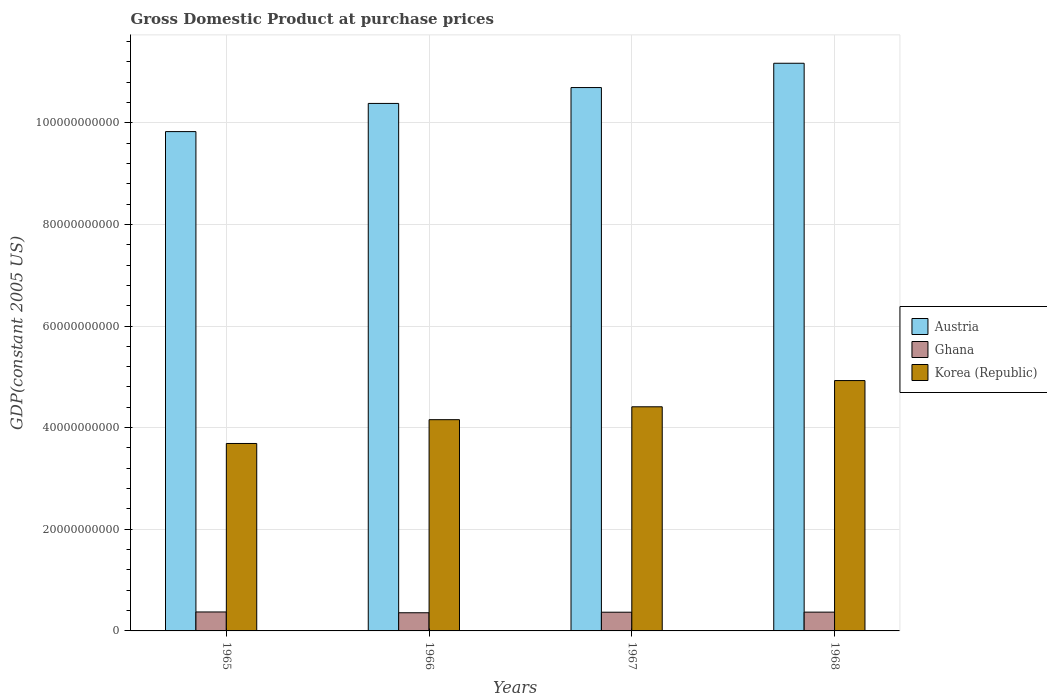How many groups of bars are there?
Offer a very short reply. 4. Are the number of bars on each tick of the X-axis equal?
Keep it short and to the point. Yes. How many bars are there on the 3rd tick from the right?
Your answer should be compact. 3. What is the label of the 3rd group of bars from the left?
Make the answer very short. 1967. In how many cases, is the number of bars for a given year not equal to the number of legend labels?
Your response must be concise. 0. What is the GDP at purchase prices in Austria in 1966?
Ensure brevity in your answer.  1.04e+11. Across all years, what is the maximum GDP at purchase prices in Ghana?
Your answer should be very brief. 3.73e+09. Across all years, what is the minimum GDP at purchase prices in Ghana?
Your response must be concise. 3.57e+09. In which year was the GDP at purchase prices in Korea (Republic) maximum?
Ensure brevity in your answer.  1968. In which year was the GDP at purchase prices in Korea (Republic) minimum?
Your response must be concise. 1965. What is the total GDP at purchase prices in Ghana in the graph?
Provide a short and direct response. 1.47e+1. What is the difference between the GDP at purchase prices in Austria in 1965 and that in 1968?
Keep it short and to the point. -1.34e+1. What is the difference between the GDP at purchase prices in Ghana in 1968 and the GDP at purchase prices in Austria in 1965?
Provide a succinct answer. -9.46e+1. What is the average GDP at purchase prices in Ghana per year?
Make the answer very short. 3.67e+09. In the year 1967, what is the difference between the GDP at purchase prices in Korea (Republic) and GDP at purchase prices in Austria?
Your answer should be very brief. -6.28e+1. In how many years, is the GDP at purchase prices in Korea (Republic) greater than 8000000000 US$?
Make the answer very short. 4. What is the ratio of the GDP at purchase prices in Austria in 1965 to that in 1968?
Ensure brevity in your answer.  0.88. What is the difference between the highest and the second highest GDP at purchase prices in Ghana?
Ensure brevity in your answer.  3.54e+07. What is the difference between the highest and the lowest GDP at purchase prices in Korea (Republic)?
Provide a succinct answer. 1.24e+1. In how many years, is the GDP at purchase prices in Ghana greater than the average GDP at purchase prices in Ghana taken over all years?
Provide a succinct answer. 3. Is the sum of the GDP at purchase prices in Austria in 1965 and 1967 greater than the maximum GDP at purchase prices in Korea (Republic) across all years?
Provide a succinct answer. Yes. What does the 1st bar from the left in 1968 represents?
Keep it short and to the point. Austria. How many bars are there?
Offer a terse response. 12. How many legend labels are there?
Keep it short and to the point. 3. How are the legend labels stacked?
Offer a terse response. Vertical. What is the title of the graph?
Provide a short and direct response. Gross Domestic Product at purchase prices. Does "Hong Kong" appear as one of the legend labels in the graph?
Provide a short and direct response. No. What is the label or title of the Y-axis?
Provide a succinct answer. GDP(constant 2005 US). What is the GDP(constant 2005 US) in Austria in 1965?
Ensure brevity in your answer.  9.83e+1. What is the GDP(constant 2005 US) of Ghana in 1965?
Your answer should be compact. 3.73e+09. What is the GDP(constant 2005 US) in Korea (Republic) in 1965?
Your answer should be very brief. 3.69e+1. What is the GDP(constant 2005 US) in Austria in 1966?
Your answer should be compact. 1.04e+11. What is the GDP(constant 2005 US) in Ghana in 1966?
Offer a very short reply. 3.57e+09. What is the GDP(constant 2005 US) of Korea (Republic) in 1966?
Your response must be concise. 4.16e+1. What is the GDP(constant 2005 US) of Austria in 1967?
Offer a terse response. 1.07e+11. What is the GDP(constant 2005 US) in Ghana in 1967?
Provide a short and direct response. 3.68e+09. What is the GDP(constant 2005 US) of Korea (Republic) in 1967?
Provide a short and direct response. 4.41e+1. What is the GDP(constant 2005 US) of Austria in 1968?
Your answer should be very brief. 1.12e+11. What is the GDP(constant 2005 US) in Ghana in 1968?
Offer a terse response. 3.70e+09. What is the GDP(constant 2005 US) of Korea (Republic) in 1968?
Give a very brief answer. 4.93e+1. Across all years, what is the maximum GDP(constant 2005 US) of Austria?
Your answer should be compact. 1.12e+11. Across all years, what is the maximum GDP(constant 2005 US) of Ghana?
Ensure brevity in your answer.  3.73e+09. Across all years, what is the maximum GDP(constant 2005 US) of Korea (Republic)?
Provide a short and direct response. 4.93e+1. Across all years, what is the minimum GDP(constant 2005 US) in Austria?
Ensure brevity in your answer.  9.83e+1. Across all years, what is the minimum GDP(constant 2005 US) of Ghana?
Provide a short and direct response. 3.57e+09. Across all years, what is the minimum GDP(constant 2005 US) in Korea (Republic)?
Offer a very short reply. 3.69e+1. What is the total GDP(constant 2005 US) in Austria in the graph?
Provide a succinct answer. 4.21e+11. What is the total GDP(constant 2005 US) of Ghana in the graph?
Your answer should be compact. 1.47e+1. What is the total GDP(constant 2005 US) in Korea (Republic) in the graph?
Give a very brief answer. 1.72e+11. What is the difference between the GDP(constant 2005 US) of Austria in 1965 and that in 1966?
Provide a short and direct response. -5.54e+09. What is the difference between the GDP(constant 2005 US) of Ghana in 1965 and that in 1966?
Ensure brevity in your answer.  1.59e+08. What is the difference between the GDP(constant 2005 US) in Korea (Republic) in 1965 and that in 1966?
Your response must be concise. -4.68e+09. What is the difference between the GDP(constant 2005 US) in Austria in 1965 and that in 1967?
Your response must be concise. -8.67e+09. What is the difference between the GDP(constant 2005 US) of Ghana in 1965 and that in 1967?
Your response must be concise. 4.90e+07. What is the difference between the GDP(constant 2005 US) of Korea (Republic) in 1965 and that in 1967?
Your answer should be compact. -7.22e+09. What is the difference between the GDP(constant 2005 US) of Austria in 1965 and that in 1968?
Give a very brief answer. -1.34e+1. What is the difference between the GDP(constant 2005 US) in Ghana in 1965 and that in 1968?
Offer a very short reply. 3.54e+07. What is the difference between the GDP(constant 2005 US) of Korea (Republic) in 1965 and that in 1968?
Your answer should be compact. -1.24e+1. What is the difference between the GDP(constant 2005 US) of Austria in 1966 and that in 1967?
Your answer should be very brief. -3.12e+09. What is the difference between the GDP(constant 2005 US) in Ghana in 1966 and that in 1967?
Provide a succinct answer. -1.10e+08. What is the difference between the GDP(constant 2005 US) of Korea (Republic) in 1966 and that in 1967?
Give a very brief answer. -2.54e+09. What is the difference between the GDP(constant 2005 US) of Austria in 1966 and that in 1968?
Provide a short and direct response. -7.90e+09. What is the difference between the GDP(constant 2005 US) of Ghana in 1966 and that in 1968?
Your response must be concise. -1.23e+08. What is the difference between the GDP(constant 2005 US) of Korea (Republic) in 1966 and that in 1968?
Keep it short and to the point. -7.70e+09. What is the difference between the GDP(constant 2005 US) of Austria in 1967 and that in 1968?
Your answer should be very brief. -4.78e+09. What is the difference between the GDP(constant 2005 US) of Ghana in 1967 and that in 1968?
Your answer should be very brief. -1.36e+07. What is the difference between the GDP(constant 2005 US) of Korea (Republic) in 1967 and that in 1968?
Your answer should be very brief. -5.16e+09. What is the difference between the GDP(constant 2005 US) in Austria in 1965 and the GDP(constant 2005 US) in Ghana in 1966?
Ensure brevity in your answer.  9.47e+1. What is the difference between the GDP(constant 2005 US) in Austria in 1965 and the GDP(constant 2005 US) in Korea (Republic) in 1966?
Ensure brevity in your answer.  5.67e+1. What is the difference between the GDP(constant 2005 US) in Ghana in 1965 and the GDP(constant 2005 US) in Korea (Republic) in 1966?
Your answer should be compact. -3.78e+1. What is the difference between the GDP(constant 2005 US) in Austria in 1965 and the GDP(constant 2005 US) in Ghana in 1967?
Provide a succinct answer. 9.46e+1. What is the difference between the GDP(constant 2005 US) in Austria in 1965 and the GDP(constant 2005 US) in Korea (Republic) in 1967?
Offer a terse response. 5.42e+1. What is the difference between the GDP(constant 2005 US) in Ghana in 1965 and the GDP(constant 2005 US) in Korea (Republic) in 1967?
Your response must be concise. -4.04e+1. What is the difference between the GDP(constant 2005 US) of Austria in 1965 and the GDP(constant 2005 US) of Ghana in 1968?
Make the answer very short. 9.46e+1. What is the difference between the GDP(constant 2005 US) of Austria in 1965 and the GDP(constant 2005 US) of Korea (Republic) in 1968?
Provide a short and direct response. 4.90e+1. What is the difference between the GDP(constant 2005 US) in Ghana in 1965 and the GDP(constant 2005 US) in Korea (Republic) in 1968?
Your response must be concise. -4.55e+1. What is the difference between the GDP(constant 2005 US) in Austria in 1966 and the GDP(constant 2005 US) in Ghana in 1967?
Your response must be concise. 1.00e+11. What is the difference between the GDP(constant 2005 US) of Austria in 1966 and the GDP(constant 2005 US) of Korea (Republic) in 1967?
Your answer should be compact. 5.97e+1. What is the difference between the GDP(constant 2005 US) in Ghana in 1966 and the GDP(constant 2005 US) in Korea (Republic) in 1967?
Give a very brief answer. -4.05e+1. What is the difference between the GDP(constant 2005 US) in Austria in 1966 and the GDP(constant 2005 US) in Ghana in 1968?
Make the answer very short. 1.00e+11. What is the difference between the GDP(constant 2005 US) in Austria in 1966 and the GDP(constant 2005 US) in Korea (Republic) in 1968?
Provide a succinct answer. 5.45e+1. What is the difference between the GDP(constant 2005 US) in Ghana in 1966 and the GDP(constant 2005 US) in Korea (Republic) in 1968?
Your answer should be very brief. -4.57e+1. What is the difference between the GDP(constant 2005 US) of Austria in 1967 and the GDP(constant 2005 US) of Ghana in 1968?
Offer a terse response. 1.03e+11. What is the difference between the GDP(constant 2005 US) in Austria in 1967 and the GDP(constant 2005 US) in Korea (Republic) in 1968?
Your answer should be compact. 5.77e+1. What is the difference between the GDP(constant 2005 US) of Ghana in 1967 and the GDP(constant 2005 US) of Korea (Republic) in 1968?
Give a very brief answer. -4.56e+1. What is the average GDP(constant 2005 US) in Austria per year?
Provide a short and direct response. 1.05e+11. What is the average GDP(constant 2005 US) of Ghana per year?
Give a very brief answer. 3.67e+09. What is the average GDP(constant 2005 US) in Korea (Republic) per year?
Ensure brevity in your answer.  4.30e+1. In the year 1965, what is the difference between the GDP(constant 2005 US) of Austria and GDP(constant 2005 US) of Ghana?
Keep it short and to the point. 9.45e+1. In the year 1965, what is the difference between the GDP(constant 2005 US) of Austria and GDP(constant 2005 US) of Korea (Republic)?
Your response must be concise. 6.14e+1. In the year 1965, what is the difference between the GDP(constant 2005 US) in Ghana and GDP(constant 2005 US) in Korea (Republic)?
Ensure brevity in your answer.  -3.32e+1. In the year 1966, what is the difference between the GDP(constant 2005 US) in Austria and GDP(constant 2005 US) in Ghana?
Your answer should be compact. 1.00e+11. In the year 1966, what is the difference between the GDP(constant 2005 US) of Austria and GDP(constant 2005 US) of Korea (Republic)?
Ensure brevity in your answer.  6.22e+1. In the year 1966, what is the difference between the GDP(constant 2005 US) in Ghana and GDP(constant 2005 US) in Korea (Republic)?
Offer a terse response. -3.80e+1. In the year 1967, what is the difference between the GDP(constant 2005 US) in Austria and GDP(constant 2005 US) in Ghana?
Offer a very short reply. 1.03e+11. In the year 1967, what is the difference between the GDP(constant 2005 US) of Austria and GDP(constant 2005 US) of Korea (Republic)?
Keep it short and to the point. 6.28e+1. In the year 1967, what is the difference between the GDP(constant 2005 US) of Ghana and GDP(constant 2005 US) of Korea (Republic)?
Offer a terse response. -4.04e+1. In the year 1968, what is the difference between the GDP(constant 2005 US) in Austria and GDP(constant 2005 US) in Ghana?
Provide a succinct answer. 1.08e+11. In the year 1968, what is the difference between the GDP(constant 2005 US) of Austria and GDP(constant 2005 US) of Korea (Republic)?
Give a very brief answer. 6.24e+1. In the year 1968, what is the difference between the GDP(constant 2005 US) of Ghana and GDP(constant 2005 US) of Korea (Republic)?
Keep it short and to the point. -4.56e+1. What is the ratio of the GDP(constant 2005 US) in Austria in 1965 to that in 1966?
Ensure brevity in your answer.  0.95. What is the ratio of the GDP(constant 2005 US) in Ghana in 1965 to that in 1966?
Your answer should be very brief. 1.04. What is the ratio of the GDP(constant 2005 US) in Korea (Republic) in 1965 to that in 1966?
Make the answer very short. 0.89. What is the ratio of the GDP(constant 2005 US) in Austria in 1965 to that in 1967?
Your answer should be compact. 0.92. What is the ratio of the GDP(constant 2005 US) of Ghana in 1965 to that in 1967?
Your answer should be compact. 1.01. What is the ratio of the GDP(constant 2005 US) in Korea (Republic) in 1965 to that in 1967?
Make the answer very short. 0.84. What is the ratio of the GDP(constant 2005 US) in Austria in 1965 to that in 1968?
Give a very brief answer. 0.88. What is the ratio of the GDP(constant 2005 US) of Ghana in 1965 to that in 1968?
Offer a very short reply. 1.01. What is the ratio of the GDP(constant 2005 US) in Korea (Republic) in 1965 to that in 1968?
Provide a short and direct response. 0.75. What is the ratio of the GDP(constant 2005 US) in Austria in 1966 to that in 1967?
Offer a very short reply. 0.97. What is the ratio of the GDP(constant 2005 US) in Ghana in 1966 to that in 1967?
Make the answer very short. 0.97. What is the ratio of the GDP(constant 2005 US) in Korea (Republic) in 1966 to that in 1967?
Ensure brevity in your answer.  0.94. What is the ratio of the GDP(constant 2005 US) of Austria in 1966 to that in 1968?
Your answer should be very brief. 0.93. What is the ratio of the GDP(constant 2005 US) in Ghana in 1966 to that in 1968?
Your answer should be very brief. 0.97. What is the ratio of the GDP(constant 2005 US) in Korea (Republic) in 1966 to that in 1968?
Provide a short and direct response. 0.84. What is the ratio of the GDP(constant 2005 US) in Austria in 1967 to that in 1968?
Provide a short and direct response. 0.96. What is the ratio of the GDP(constant 2005 US) in Korea (Republic) in 1967 to that in 1968?
Offer a very short reply. 0.9. What is the difference between the highest and the second highest GDP(constant 2005 US) of Austria?
Ensure brevity in your answer.  4.78e+09. What is the difference between the highest and the second highest GDP(constant 2005 US) of Ghana?
Provide a short and direct response. 3.54e+07. What is the difference between the highest and the second highest GDP(constant 2005 US) in Korea (Republic)?
Ensure brevity in your answer.  5.16e+09. What is the difference between the highest and the lowest GDP(constant 2005 US) of Austria?
Keep it short and to the point. 1.34e+1. What is the difference between the highest and the lowest GDP(constant 2005 US) in Ghana?
Offer a very short reply. 1.59e+08. What is the difference between the highest and the lowest GDP(constant 2005 US) of Korea (Republic)?
Your answer should be compact. 1.24e+1. 